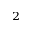<formula> <loc_0><loc_0><loc_500><loc_500>^ { 2 }</formula> 